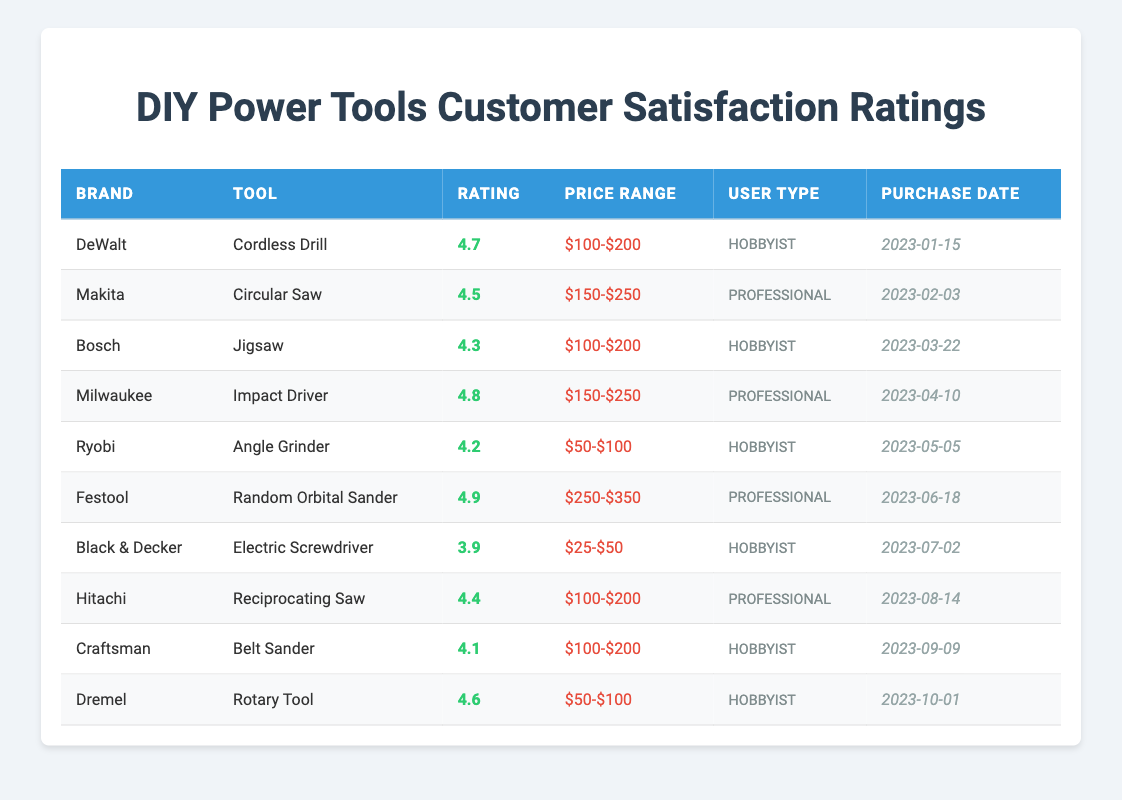What is the rating of the Dremel Rotary Tool? The table shows the details for the Dremel Rotary Tool, and it lists the rating as 4.6.
Answer: 4.6 Which tool has the highest customer satisfaction rating? Looking through the table, the tool with the highest rating is the Festool Random Orbital Sander, which has a rating of 4.9.
Answer: Festool Random Orbital Sander How many DIY power tools have ratings above 4.5? Checking the ratings in the table, the tools with ratings above 4.5 are DeWalt Cordless Drill (4.7), Milwaukee Impact Driver (4.8), and Festool Random Orbital Sander (4.9). That makes a total of 3 tools above 4.5.
Answer: 3 Is the Black & Decker Electric Screwdriver rated above 4.0? The rating for the Black & Decker Electric Screwdriver is listed as 3.9, which is below 4.0. So the answer is no.
Answer: No What is the average rating for all Hobbyist tools? Looking at the ratings for Hobbyist tools: DeWalt Cordless Drill (4.7), Bosch Jigsaw (4.3), Ryobi Angle Grinder (4.2), Black & Decker Electric Screwdriver (3.9), Craftsman Belt Sander (4.1), and Dremel Rotary Tool (4.6). Summing these ratings gives 4.7 + 4.3 + 4.2 + 3.9 + 4.1 + 4.6 = 26. Since there are 6 Hobbyist tools, the average rating is 26/6 = 4.33.
Answer: 4.33 Which user type has the tool with the lowest rating? The table shows the Black & Decker Electric Screwdriver has the lowest rating at 3.9, and it is categorized as a Hobbyist tool.
Answer: Hobbyist How many tools in the price range of $100-$200 have a rating higher than 4.0? The tools in the $100-$200 price range with ratings are DeWalt Cordless Drill (4.7), Bosch Jigsaw (4.3), Hitachi Reciprocating Saw (4.4), and Craftsman Belt Sander (4.1). Among these, all have ratings higher than 4.0, so there are 4 tools in this category.
Answer: 4 Is there any Professional tool with a rating below 4.0? Reviewing the table, the lowest rating for Professional tools are Makita Circular Saw (4.5), Milwaukee Impact Driver (4.8), and Hitachi Reciprocating Saw (4.4). None are below 4.0, meaning the answer is no.
Answer: No What is the price range of the tool with the highest rating? The tool with the highest rating is the Festool Random Orbital Sander, and its price range is listed as $250-$350.
Answer: $250-$350 